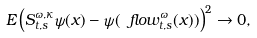Convert formula to latex. <formula><loc_0><loc_0><loc_500><loc_500>E \left ( S _ { t , s } ^ { \omega , \kappa } \psi ( { x } ) - \psi ( \ f l o w ^ { \omega } _ { t , s } ( { x } ) ) \right ) ^ { 2 } \to 0 ,</formula> 